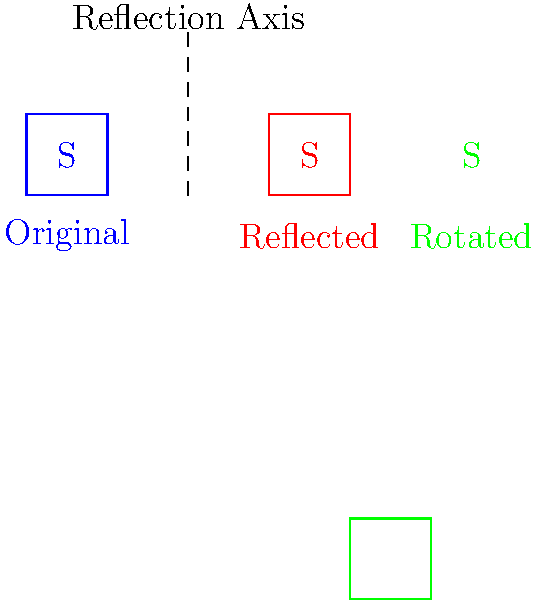Shane Koyczan, known for his powerful spoken word poetry, has stylized his signature using transformational geometry. In the image above, you can see three versions of Koyczan's initial "S". Identify the transformations applied to create the red and green versions of the signature from the original blue one. To identify the transformations, let's analyze each modified signature:

1. Red Signature:
   - The red "S" is a mirror image of the original blue "S".
   - There's a vertical dashed line between the blue and red signatures.
   - This indicates a reflection across a vertical line.

2. Green Signature:
   - The green "S" appears to be turned 90 degrees compared to the original.
   - The orientation has changed from vertical to horizontal.
   - This suggests a 90-degree rotation.

Step-by-step analysis:
1. Reflection (Red "S"):
   - The red "S" is flipped horizontally but maintains its vertical orientation.
   - It's reflected across the vertical dashed line (reflection axis).
   - This transformation is a reflection across the y-axis (or a vertical line).

2. Rotation (Green "S"):
   - The green "S" has been turned so that what was the bottom of the "S" is now on the left side.
   - This is consistent with a 90-degree counterclockwise rotation.
   - The center of rotation appears to be the bottom-left corner of the original "S".

Therefore, the transformations applied are:
- Red "S": Reflection across a vertical line
- Green "S": 90-degree counterclockwise rotation
Answer: Reflection and rotation 